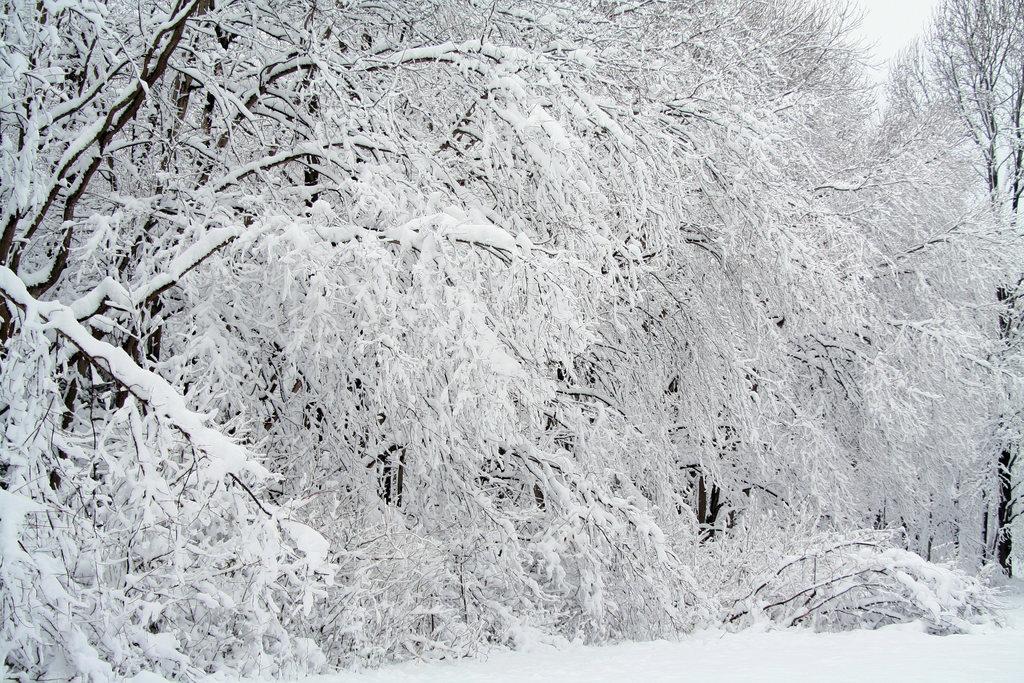In one or two sentences, can you explain what this image depicts? We can see snow on the trees in the image and there is snow at the bottom side. 